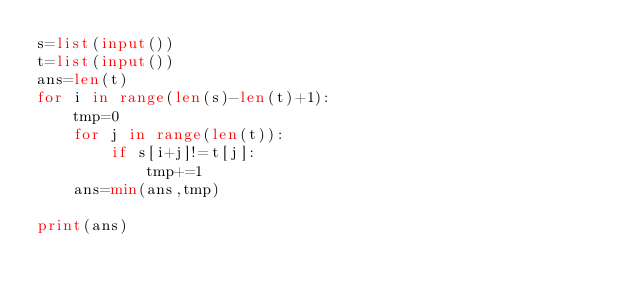<code> <loc_0><loc_0><loc_500><loc_500><_Python_>s=list(input())
t=list(input())
ans=len(t)
for i in range(len(s)-len(t)+1):
    tmp=0
    for j in range(len(t)):
        if s[i+j]!=t[j]:
            tmp+=1
    ans=min(ans,tmp)

print(ans)




</code> 